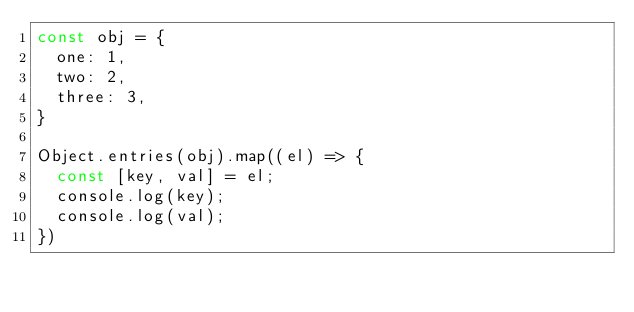<code> <loc_0><loc_0><loc_500><loc_500><_JavaScript_>const obj = {
  one: 1,
  two: 2,
  three: 3,
}

Object.entries(obj).map((el) => {
  const [key, val] = el;
  console.log(key);
  console.log(val);
})
</code> 